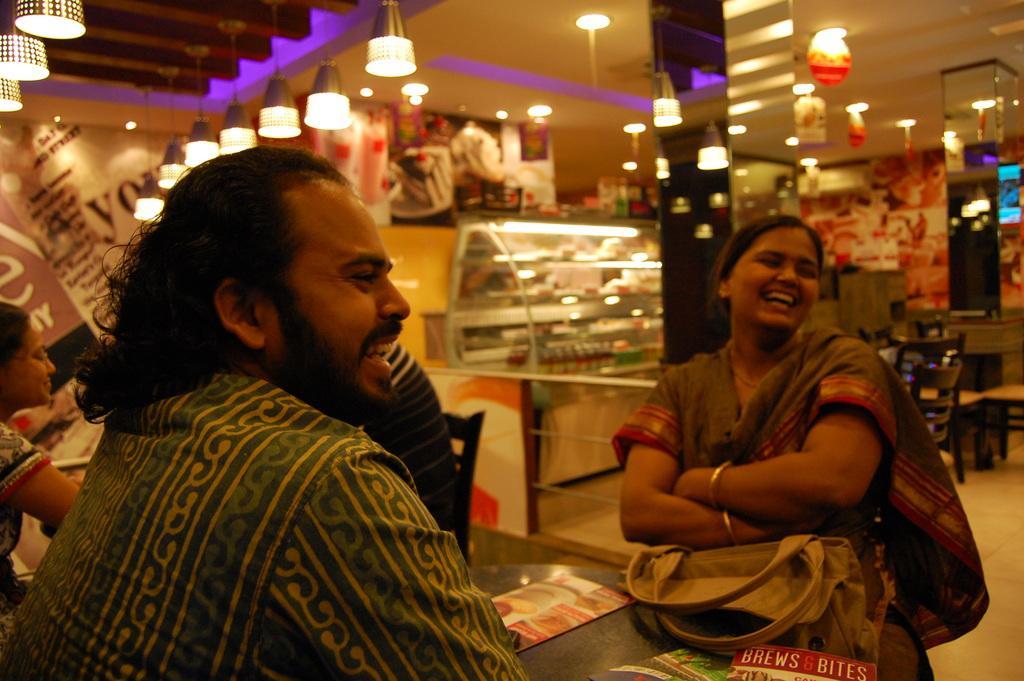Can you describe this image briefly? In this picture there are two people, one woman and one man sitting besides a table, both are laughing. In the background are some lights, lanterns and some tables. 